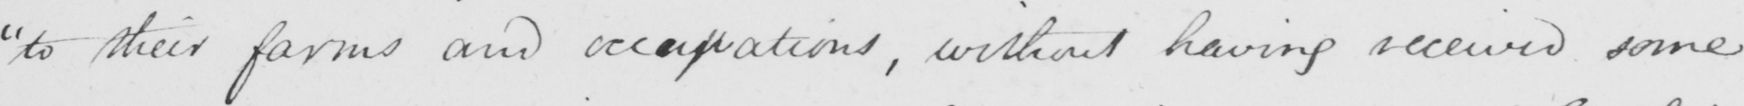Can you tell me what this handwritten text says? " to their farms and occupations , without having received some 